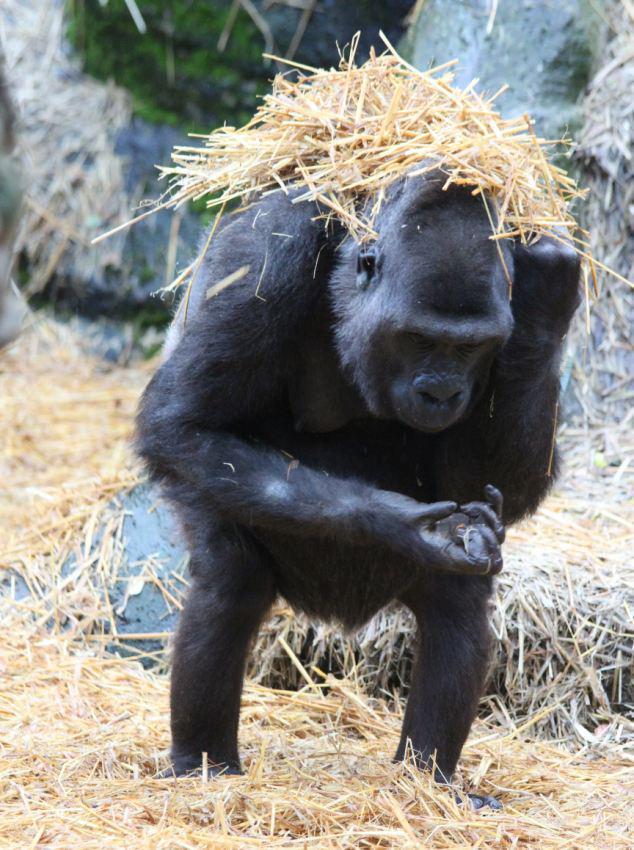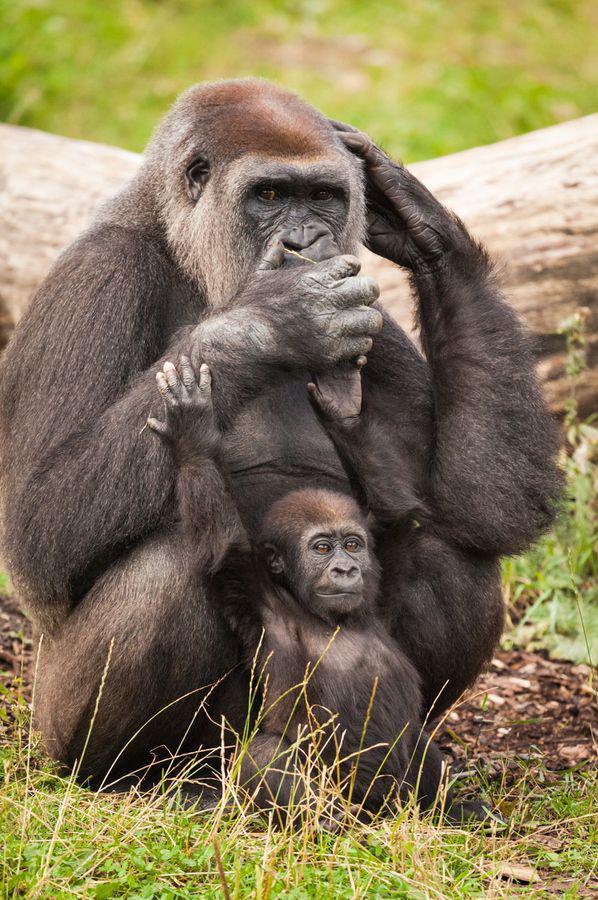The first image is the image on the left, the second image is the image on the right. Given the left and right images, does the statement "There are exactly three gorillas." hold true? Answer yes or no. Yes. 